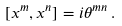Convert formula to latex. <formula><loc_0><loc_0><loc_500><loc_500>[ x ^ { m } , x ^ { n } ] = i \theta ^ { m n } \, .</formula> 